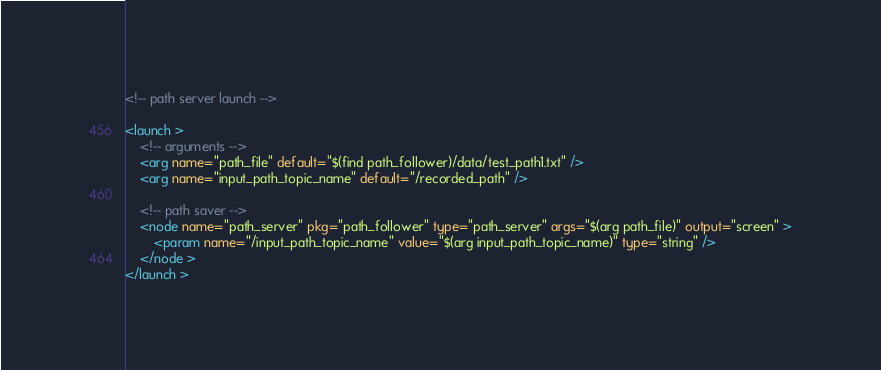Convert code to text. <code><loc_0><loc_0><loc_500><loc_500><_XML_><!-- path server launch -->

<launch >
    <!-- arguments -->
    <arg name="path_file" default="$(find path_follower)/data/test_path1.txt" />
    <arg name="input_path_topic_name" default="/recorded_path" />

    <!-- path saver -->
    <node name="path_server" pkg="path_follower" type="path_server" args="$(arg path_file)" output="screen" >
        <param name="/input_path_topic_name" value="$(arg input_path_topic_name)" type="string" />
    </node >
</launch >
</code> 